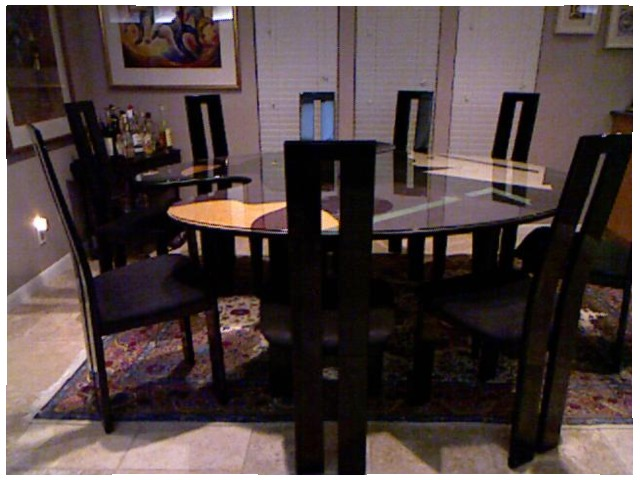<image>
Can you confirm if the table is in front of the chair? Yes. The table is positioned in front of the chair, appearing closer to the camera viewpoint. Is the dining table on the floor? Yes. Looking at the image, I can see the dining table is positioned on top of the floor, with the floor providing support. Is there a chair under the table? Yes. The chair is positioned underneath the table, with the table above it in the vertical space. Is there a table under the chair? No. The table is not positioned under the chair. The vertical relationship between these objects is different. Is the chair above the chair? No. The chair is not positioned above the chair. The vertical arrangement shows a different relationship. 